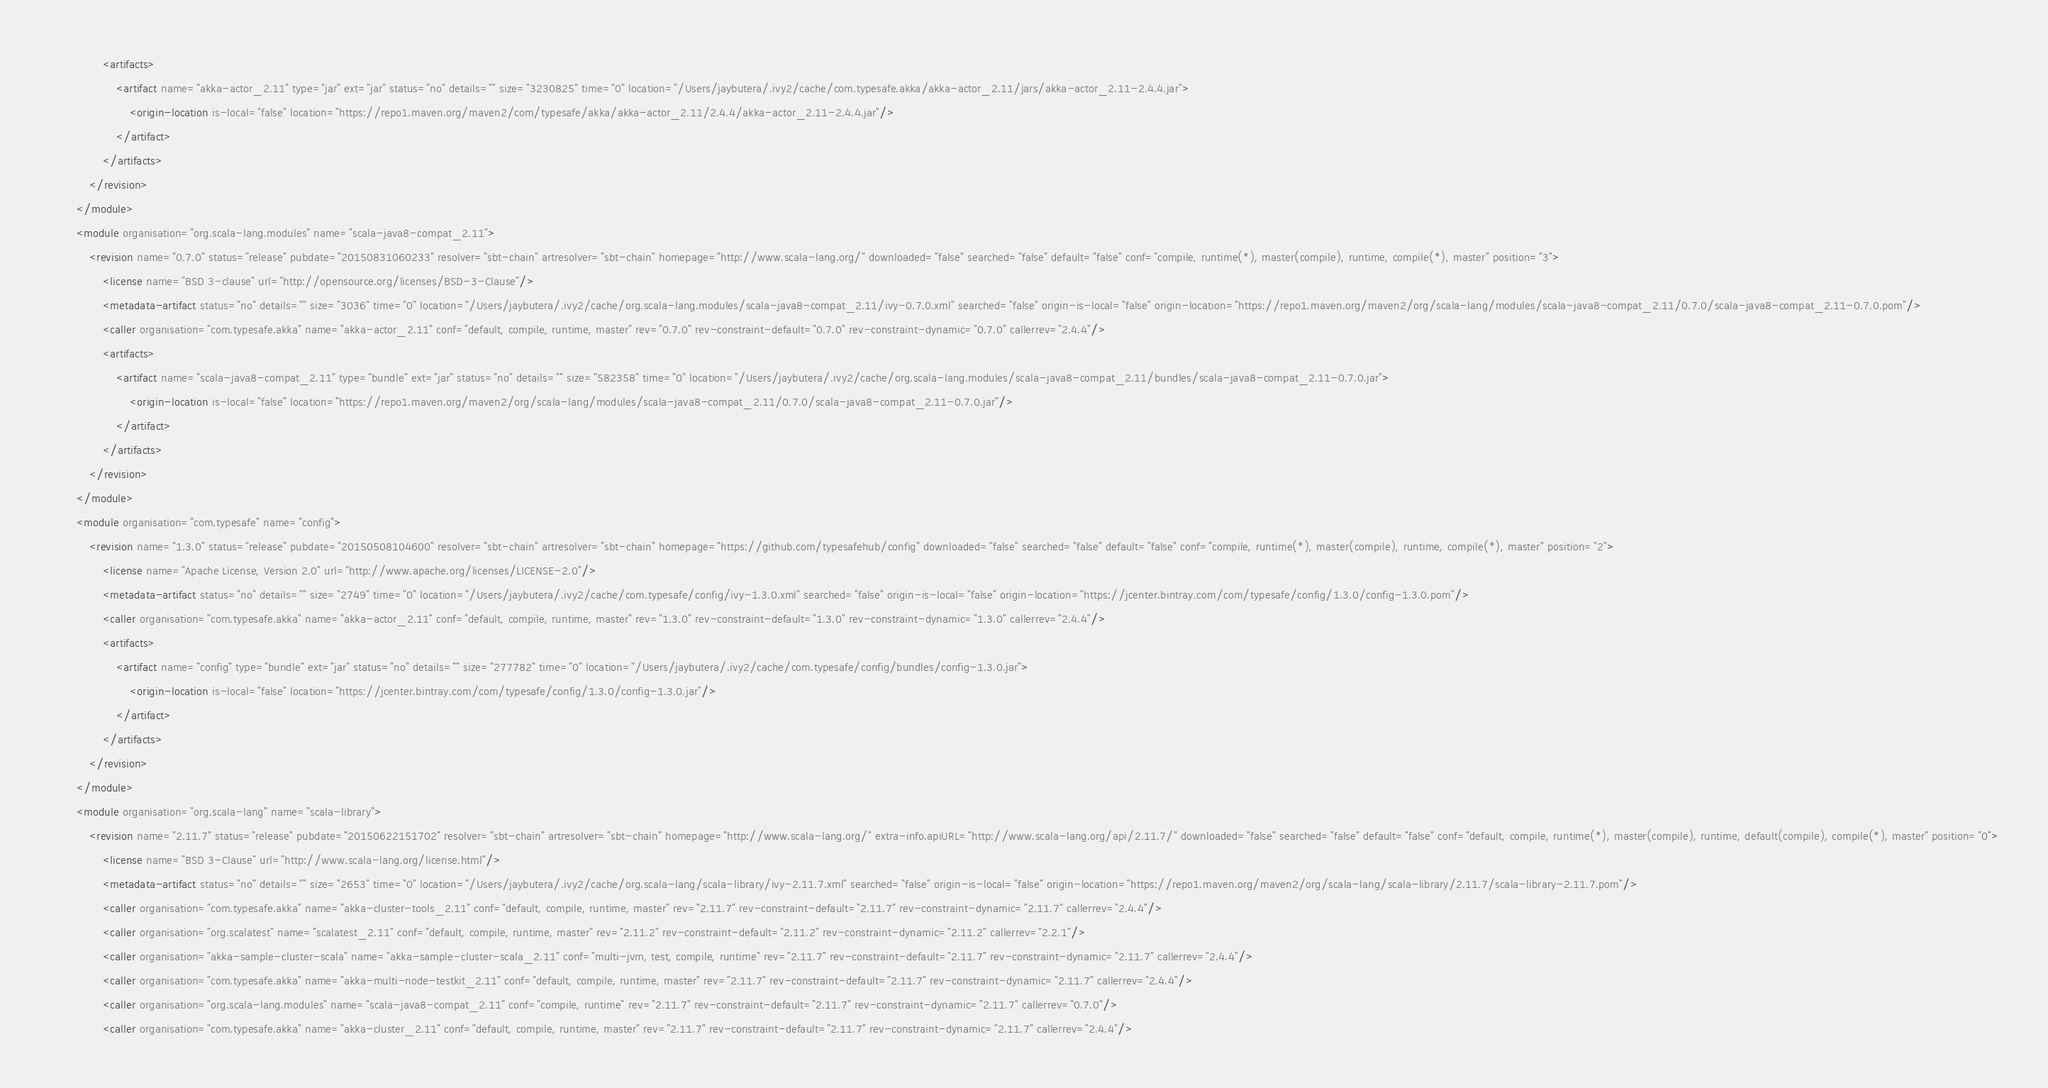Convert code to text. <code><loc_0><loc_0><loc_500><loc_500><_XML_>				<artifacts>
					<artifact name="akka-actor_2.11" type="jar" ext="jar" status="no" details="" size="3230825" time="0" location="/Users/jaybutera/.ivy2/cache/com.typesafe.akka/akka-actor_2.11/jars/akka-actor_2.11-2.4.4.jar">
						<origin-location is-local="false" location="https://repo1.maven.org/maven2/com/typesafe/akka/akka-actor_2.11/2.4.4/akka-actor_2.11-2.4.4.jar"/>
					</artifact>
				</artifacts>
			</revision>
		</module>
		<module organisation="org.scala-lang.modules" name="scala-java8-compat_2.11">
			<revision name="0.7.0" status="release" pubdate="20150831060233" resolver="sbt-chain" artresolver="sbt-chain" homepage="http://www.scala-lang.org/" downloaded="false" searched="false" default="false" conf="compile, runtime(*), master(compile), runtime, compile(*), master" position="3">
				<license name="BSD 3-clause" url="http://opensource.org/licenses/BSD-3-Clause"/>
				<metadata-artifact status="no" details="" size="3036" time="0" location="/Users/jaybutera/.ivy2/cache/org.scala-lang.modules/scala-java8-compat_2.11/ivy-0.7.0.xml" searched="false" origin-is-local="false" origin-location="https://repo1.maven.org/maven2/org/scala-lang/modules/scala-java8-compat_2.11/0.7.0/scala-java8-compat_2.11-0.7.0.pom"/>
				<caller organisation="com.typesafe.akka" name="akka-actor_2.11" conf="default, compile, runtime, master" rev="0.7.0" rev-constraint-default="0.7.0" rev-constraint-dynamic="0.7.0" callerrev="2.4.4"/>
				<artifacts>
					<artifact name="scala-java8-compat_2.11" type="bundle" ext="jar" status="no" details="" size="582358" time="0" location="/Users/jaybutera/.ivy2/cache/org.scala-lang.modules/scala-java8-compat_2.11/bundles/scala-java8-compat_2.11-0.7.0.jar">
						<origin-location is-local="false" location="https://repo1.maven.org/maven2/org/scala-lang/modules/scala-java8-compat_2.11/0.7.0/scala-java8-compat_2.11-0.7.0.jar"/>
					</artifact>
				</artifacts>
			</revision>
		</module>
		<module organisation="com.typesafe" name="config">
			<revision name="1.3.0" status="release" pubdate="20150508104600" resolver="sbt-chain" artresolver="sbt-chain" homepage="https://github.com/typesafehub/config" downloaded="false" searched="false" default="false" conf="compile, runtime(*), master(compile), runtime, compile(*), master" position="2">
				<license name="Apache License, Version 2.0" url="http://www.apache.org/licenses/LICENSE-2.0"/>
				<metadata-artifact status="no" details="" size="2749" time="0" location="/Users/jaybutera/.ivy2/cache/com.typesafe/config/ivy-1.3.0.xml" searched="false" origin-is-local="false" origin-location="https://jcenter.bintray.com/com/typesafe/config/1.3.0/config-1.3.0.pom"/>
				<caller organisation="com.typesafe.akka" name="akka-actor_2.11" conf="default, compile, runtime, master" rev="1.3.0" rev-constraint-default="1.3.0" rev-constraint-dynamic="1.3.0" callerrev="2.4.4"/>
				<artifacts>
					<artifact name="config" type="bundle" ext="jar" status="no" details="" size="277782" time="0" location="/Users/jaybutera/.ivy2/cache/com.typesafe/config/bundles/config-1.3.0.jar">
						<origin-location is-local="false" location="https://jcenter.bintray.com/com/typesafe/config/1.3.0/config-1.3.0.jar"/>
					</artifact>
				</artifacts>
			</revision>
		</module>
		<module organisation="org.scala-lang" name="scala-library">
			<revision name="2.11.7" status="release" pubdate="20150622151702" resolver="sbt-chain" artresolver="sbt-chain" homepage="http://www.scala-lang.org/" extra-info.apiURL="http://www.scala-lang.org/api/2.11.7/" downloaded="false" searched="false" default="false" conf="default, compile, runtime(*), master(compile), runtime, default(compile), compile(*), master" position="0">
				<license name="BSD 3-Clause" url="http://www.scala-lang.org/license.html"/>
				<metadata-artifact status="no" details="" size="2653" time="0" location="/Users/jaybutera/.ivy2/cache/org.scala-lang/scala-library/ivy-2.11.7.xml" searched="false" origin-is-local="false" origin-location="https://repo1.maven.org/maven2/org/scala-lang/scala-library/2.11.7/scala-library-2.11.7.pom"/>
				<caller organisation="com.typesafe.akka" name="akka-cluster-tools_2.11" conf="default, compile, runtime, master" rev="2.11.7" rev-constraint-default="2.11.7" rev-constraint-dynamic="2.11.7" callerrev="2.4.4"/>
				<caller organisation="org.scalatest" name="scalatest_2.11" conf="default, compile, runtime, master" rev="2.11.2" rev-constraint-default="2.11.2" rev-constraint-dynamic="2.11.2" callerrev="2.2.1"/>
				<caller organisation="akka-sample-cluster-scala" name="akka-sample-cluster-scala_2.11" conf="multi-jvm, test, compile, runtime" rev="2.11.7" rev-constraint-default="2.11.7" rev-constraint-dynamic="2.11.7" callerrev="2.4.4"/>
				<caller organisation="com.typesafe.akka" name="akka-multi-node-testkit_2.11" conf="default, compile, runtime, master" rev="2.11.7" rev-constraint-default="2.11.7" rev-constraint-dynamic="2.11.7" callerrev="2.4.4"/>
				<caller organisation="org.scala-lang.modules" name="scala-java8-compat_2.11" conf="compile, runtime" rev="2.11.7" rev-constraint-default="2.11.7" rev-constraint-dynamic="2.11.7" callerrev="0.7.0"/>
				<caller organisation="com.typesafe.akka" name="akka-cluster_2.11" conf="default, compile, runtime, master" rev="2.11.7" rev-constraint-default="2.11.7" rev-constraint-dynamic="2.11.7" callerrev="2.4.4"/></code> 